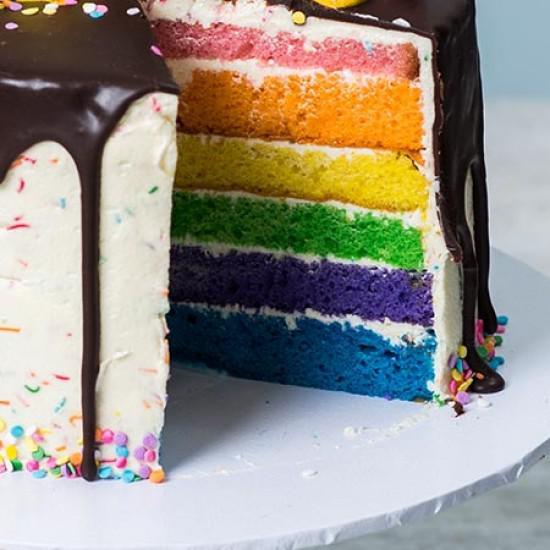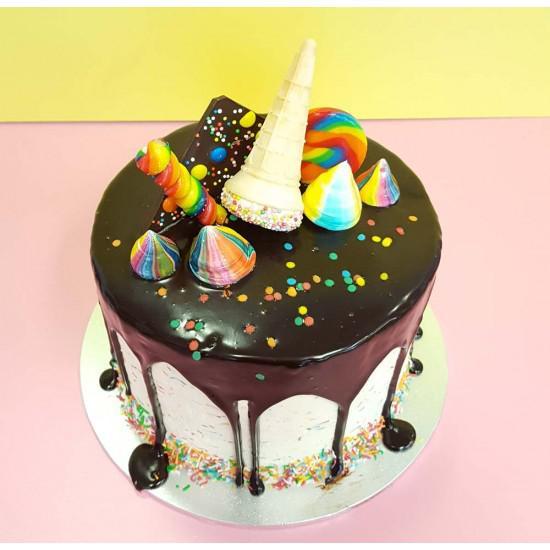The first image is the image on the left, the second image is the image on the right. Considering the images on both sides, is "In at least one image there is an ice cream cone on top of a frosting drip cake." valid? Answer yes or no. Yes. The first image is the image on the left, the second image is the image on the right. Evaluate the accuracy of this statement regarding the images: "Each image contains one cake with drip frosting effect and a ring of confetti sprinkles around the bottom, and the cake on the right has an inverted ice cream cone on its top.". Is it true? Answer yes or no. Yes. 